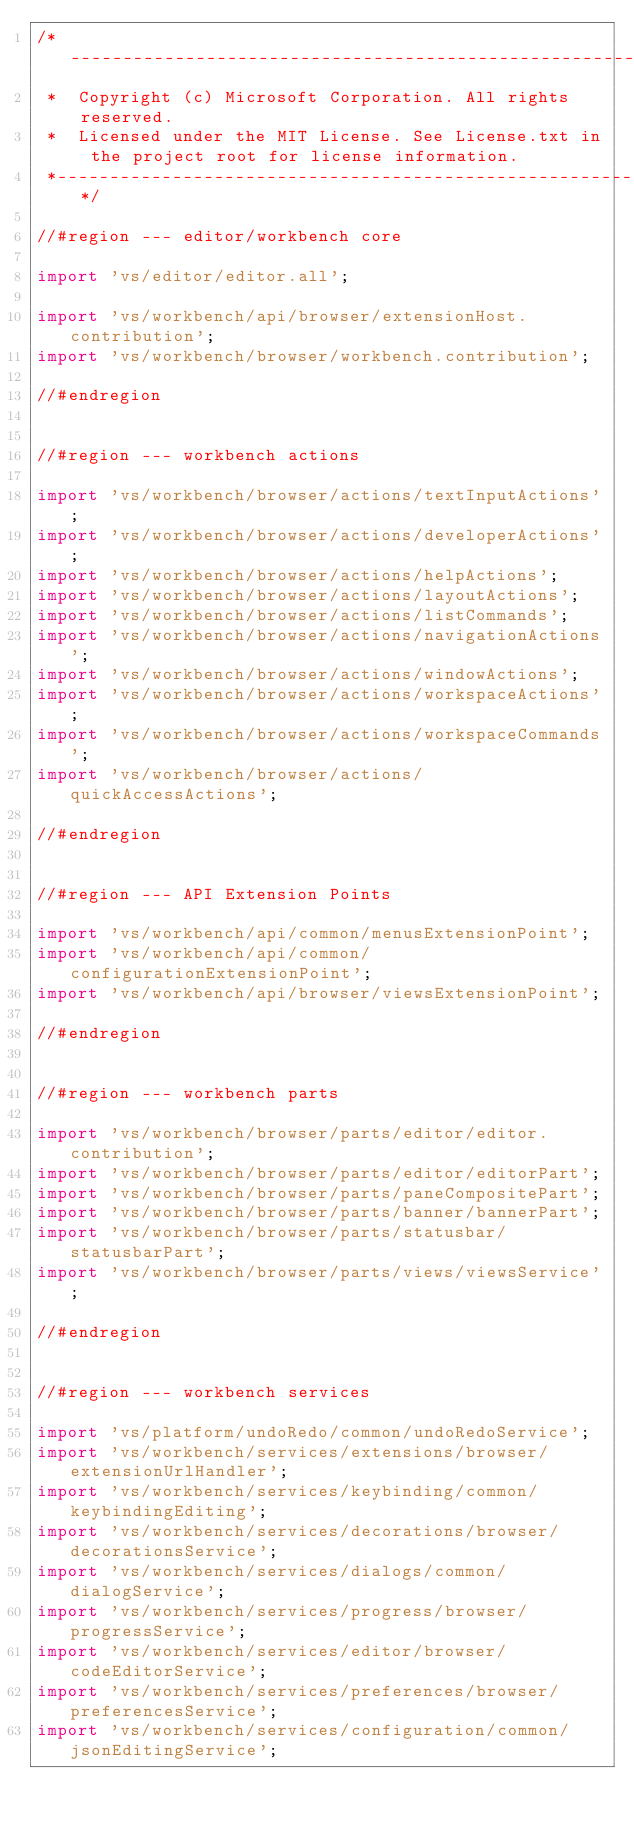<code> <loc_0><loc_0><loc_500><loc_500><_TypeScript_>/*---------------------------------------------------------------------------------------------
 *  Copyright (c) Microsoft Corporation. All rights reserved.
 *  Licensed under the MIT License. See License.txt in the project root for license information.
 *--------------------------------------------------------------------------------------------*/

//#region --- editor/workbench core

import 'vs/editor/editor.all';

import 'vs/workbench/api/browser/extensionHost.contribution';
import 'vs/workbench/browser/workbench.contribution';

//#endregion


//#region --- workbench actions

import 'vs/workbench/browser/actions/textInputActions';
import 'vs/workbench/browser/actions/developerActions';
import 'vs/workbench/browser/actions/helpActions';
import 'vs/workbench/browser/actions/layoutActions';
import 'vs/workbench/browser/actions/listCommands';
import 'vs/workbench/browser/actions/navigationActions';
import 'vs/workbench/browser/actions/windowActions';
import 'vs/workbench/browser/actions/workspaceActions';
import 'vs/workbench/browser/actions/workspaceCommands';
import 'vs/workbench/browser/actions/quickAccessActions';

//#endregion


//#region --- API Extension Points

import 'vs/workbench/api/common/menusExtensionPoint';
import 'vs/workbench/api/common/configurationExtensionPoint';
import 'vs/workbench/api/browser/viewsExtensionPoint';

//#endregion


//#region --- workbench parts

import 'vs/workbench/browser/parts/editor/editor.contribution';
import 'vs/workbench/browser/parts/editor/editorPart';
import 'vs/workbench/browser/parts/paneCompositePart';
import 'vs/workbench/browser/parts/banner/bannerPart';
import 'vs/workbench/browser/parts/statusbar/statusbarPart';
import 'vs/workbench/browser/parts/views/viewsService';

//#endregion


//#region --- workbench services

import 'vs/platform/undoRedo/common/undoRedoService';
import 'vs/workbench/services/extensions/browser/extensionUrlHandler';
import 'vs/workbench/services/keybinding/common/keybindingEditing';
import 'vs/workbench/services/decorations/browser/decorationsService';
import 'vs/workbench/services/dialogs/common/dialogService';
import 'vs/workbench/services/progress/browser/progressService';
import 'vs/workbench/services/editor/browser/codeEditorService';
import 'vs/workbench/services/preferences/browser/preferencesService';
import 'vs/workbench/services/configuration/common/jsonEditingService';</code> 